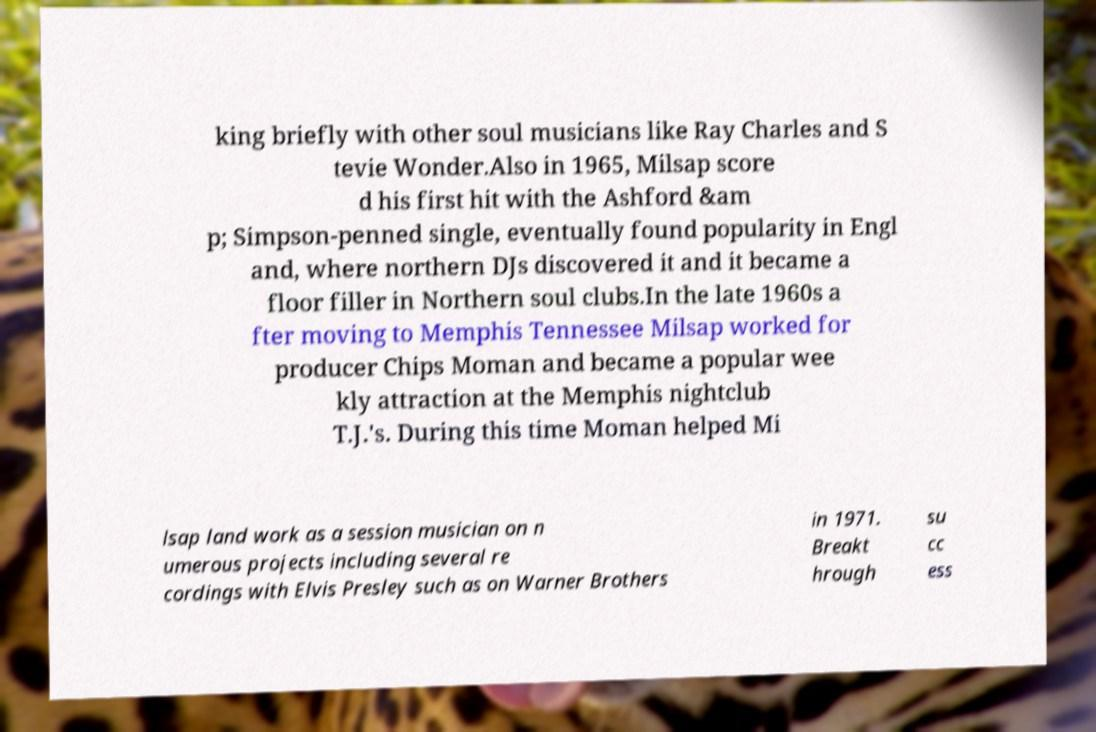Please read and relay the text visible in this image. What does it say? king briefly with other soul musicians like Ray Charles and S tevie Wonder.Also in 1965, Milsap score d his first hit with the Ashford &am p; Simpson-penned single, eventually found popularity in Engl and, where northern DJs discovered it and it became a floor filler in Northern soul clubs.In the late 1960s a fter moving to Memphis Tennessee Milsap worked for producer Chips Moman and became a popular wee kly attraction at the Memphis nightclub T.J.'s. During this time Moman helped Mi lsap land work as a session musician on n umerous projects including several re cordings with Elvis Presley such as on Warner Brothers in 1971. Breakt hrough su cc ess 